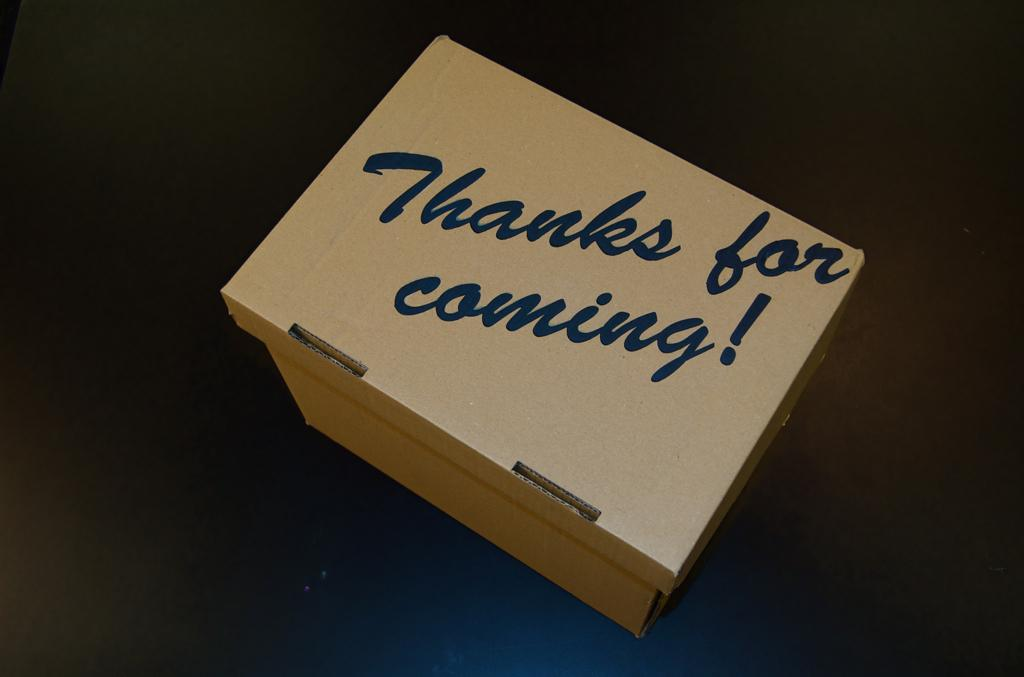Provide a one-sentence caption for the provided image. A box full of thanks for taking the time to attend the event. 